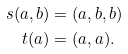Convert formula to latex. <formula><loc_0><loc_0><loc_500><loc_500>s ( a , b ) & = ( a , b , b ) \\ t ( a ) & = ( a , a ) .</formula> 